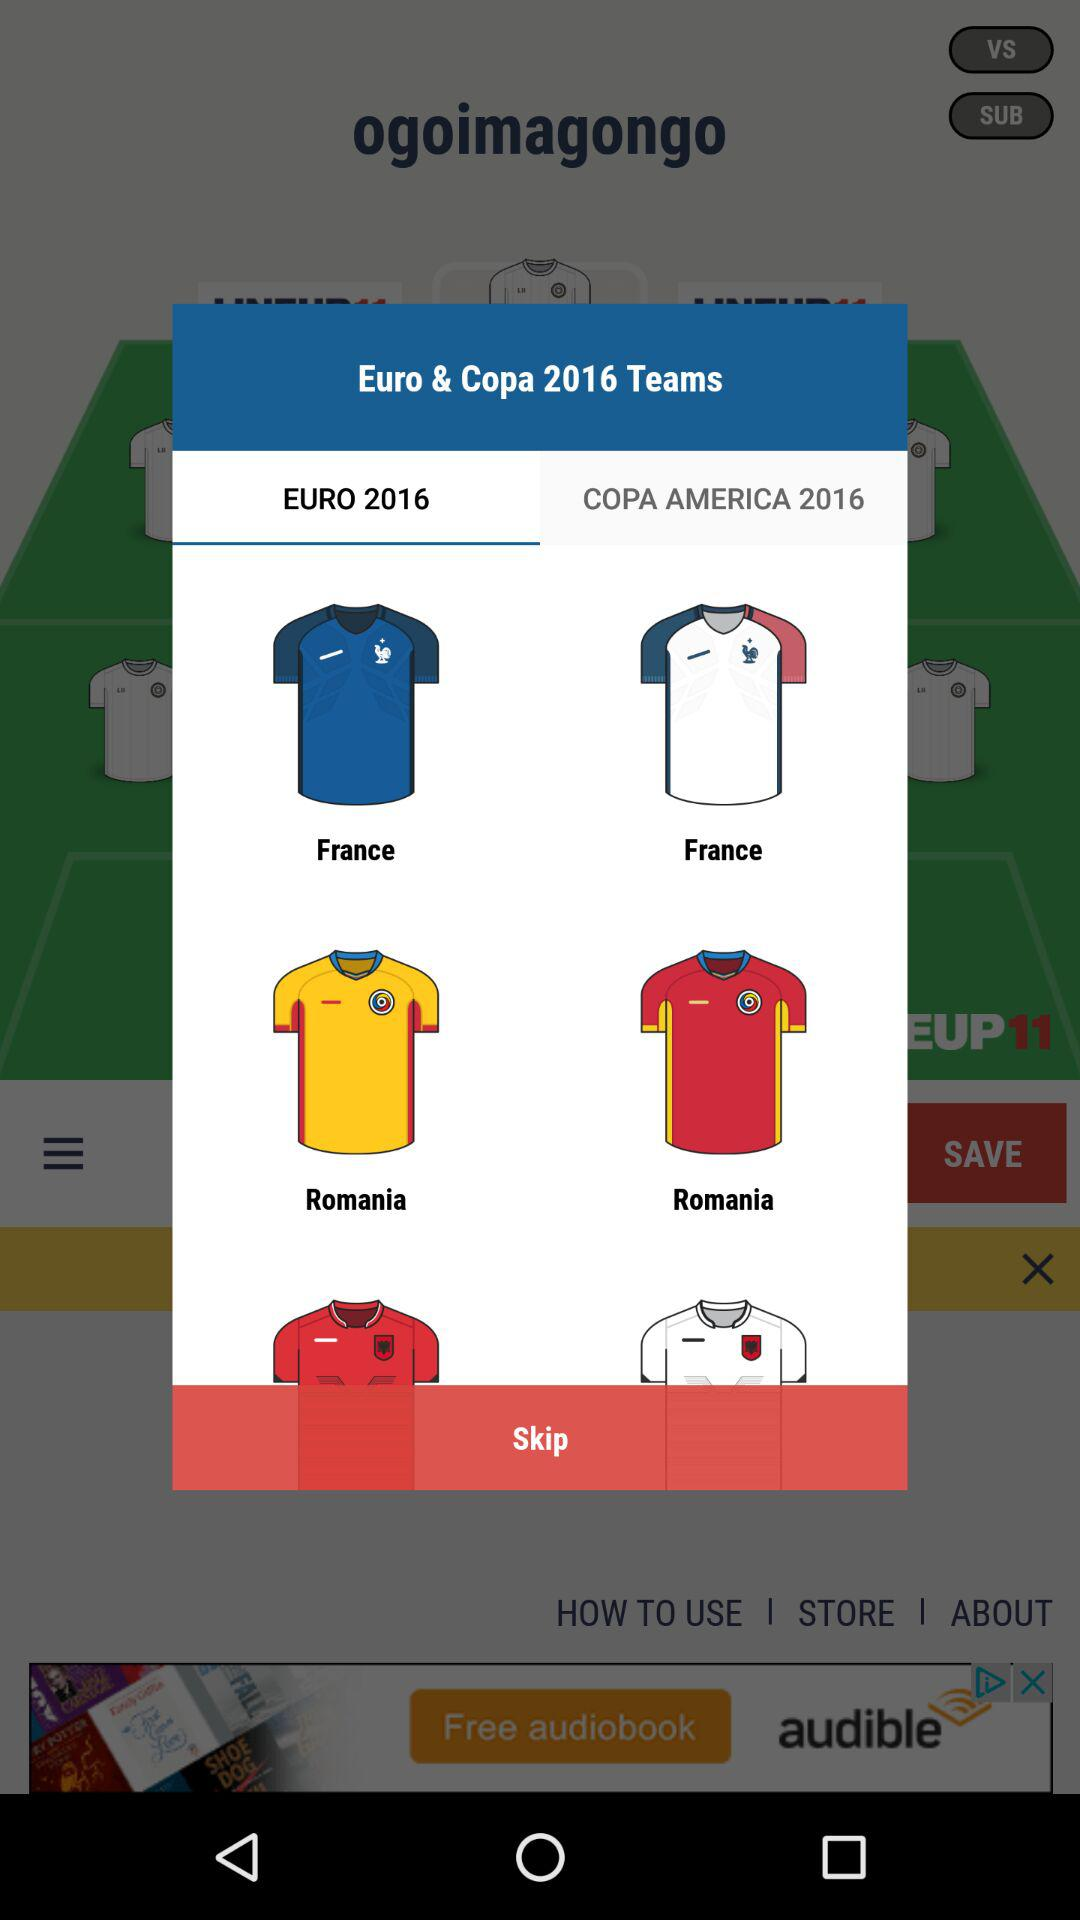Which tab is selected? The selected tab is "EURO 2016". 